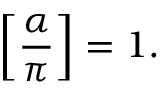Convert formula to latex. <formula><loc_0><loc_0><loc_500><loc_500>\left [ { \frac { \alpha } { \pi } } \right ] = 1 .</formula> 